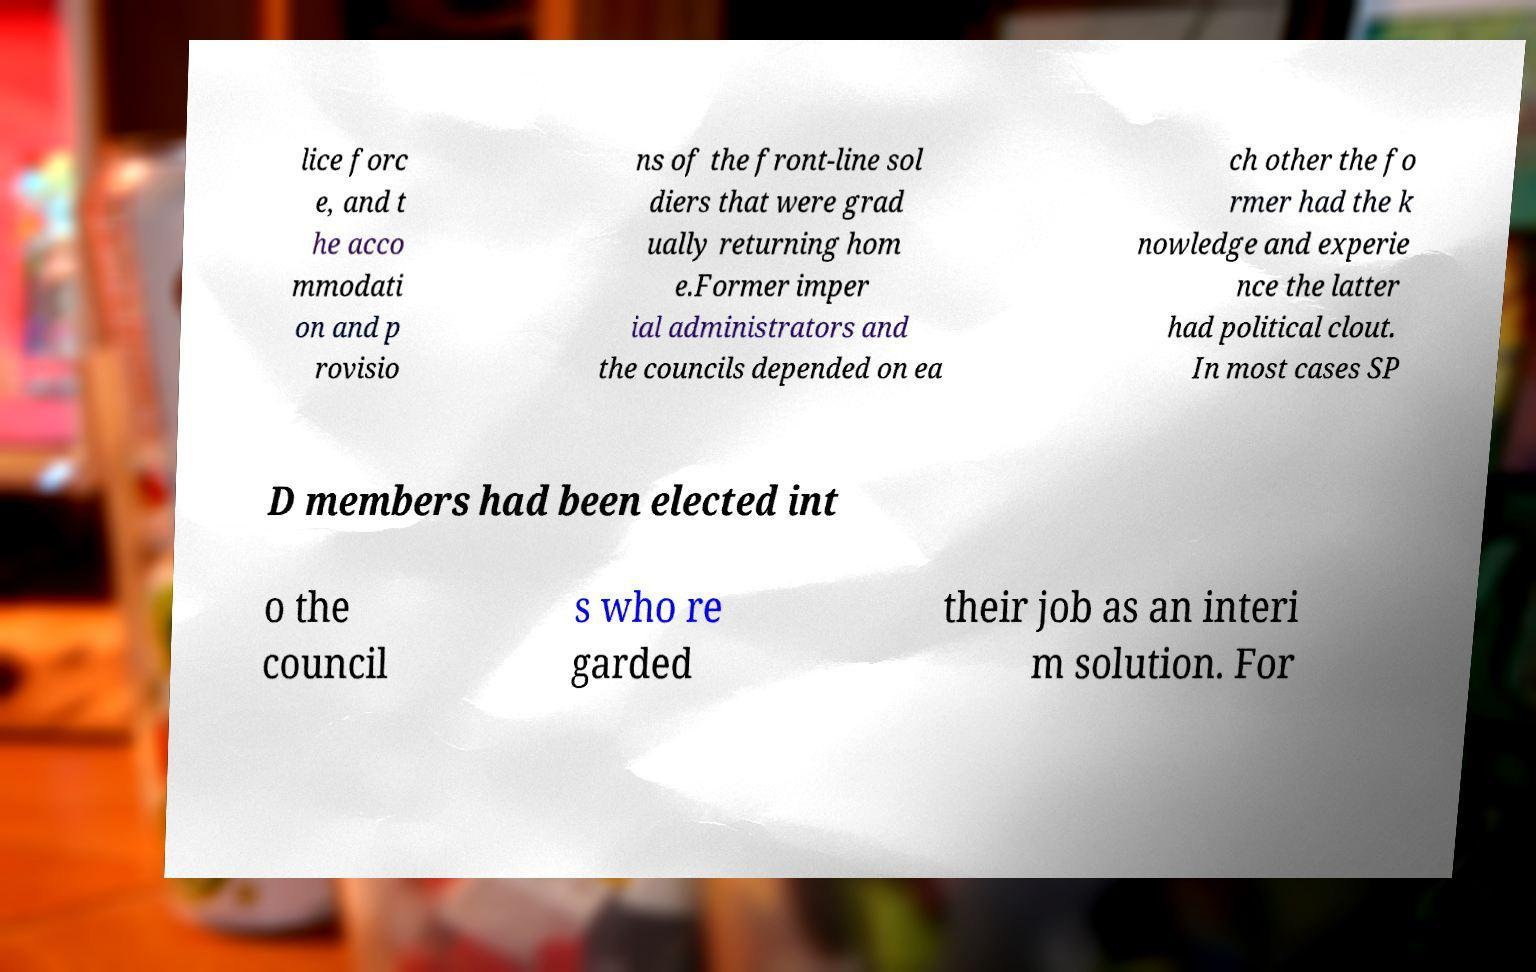Can you read and provide the text displayed in the image?This photo seems to have some interesting text. Can you extract and type it out for me? lice forc e, and t he acco mmodati on and p rovisio ns of the front-line sol diers that were grad ually returning hom e.Former imper ial administrators and the councils depended on ea ch other the fo rmer had the k nowledge and experie nce the latter had political clout. In most cases SP D members had been elected int o the council s who re garded their job as an interi m solution. For 